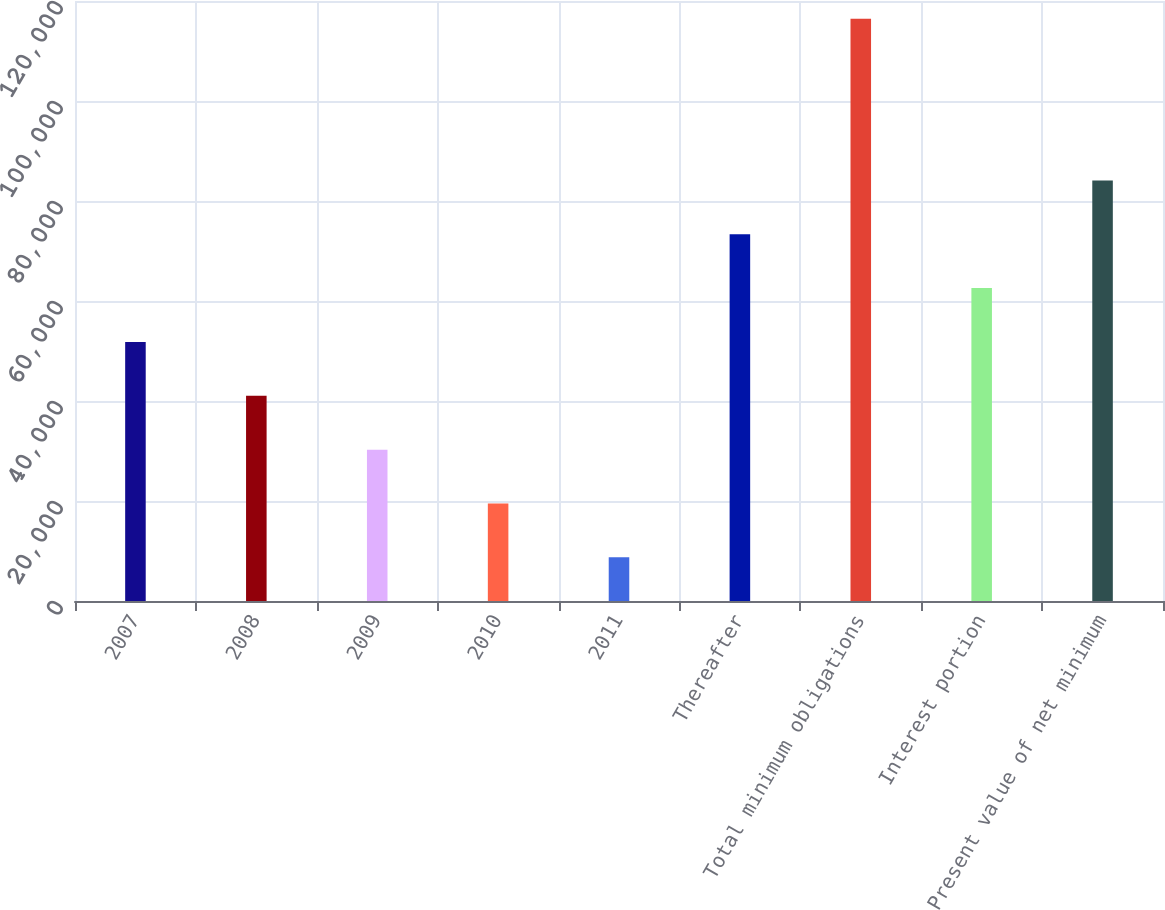<chart> <loc_0><loc_0><loc_500><loc_500><bar_chart><fcel>2007<fcel>2008<fcel>2009<fcel>2010<fcel>2011<fcel>Thereafter<fcel>Total minimum obligations<fcel>Interest portion<fcel>Present value of net minimum<nl><fcel>51814.6<fcel>41044.7<fcel>30274.8<fcel>19504.9<fcel>8735<fcel>73354.4<fcel>116434<fcel>62584.5<fcel>84124.3<nl></chart> 